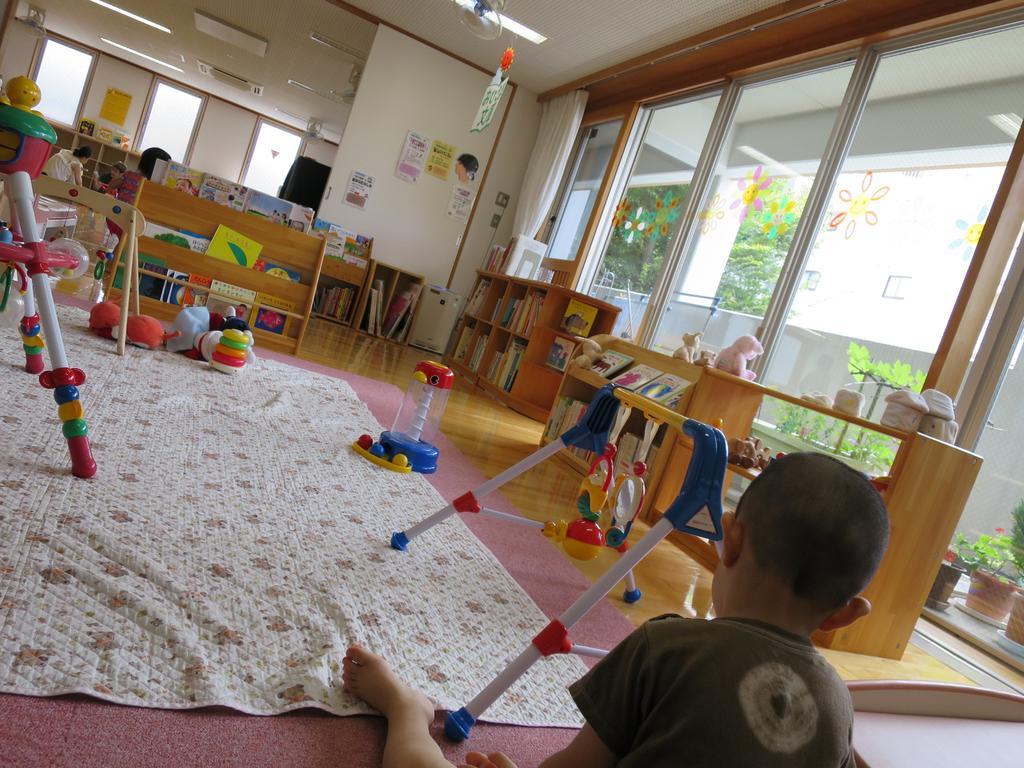Please provide a concise description of this image. At the bottom of this image, there is a child sitting on the floor and placing a leg on the cloth, on which there are toys arranged. In the background, there are books arranged on the shelves, there are lights attached to the roof, there are glass windows and there are posters pasted on the wall. Though these glass windows, we can see there are potted plants, a white wall, there are trees and another building. 